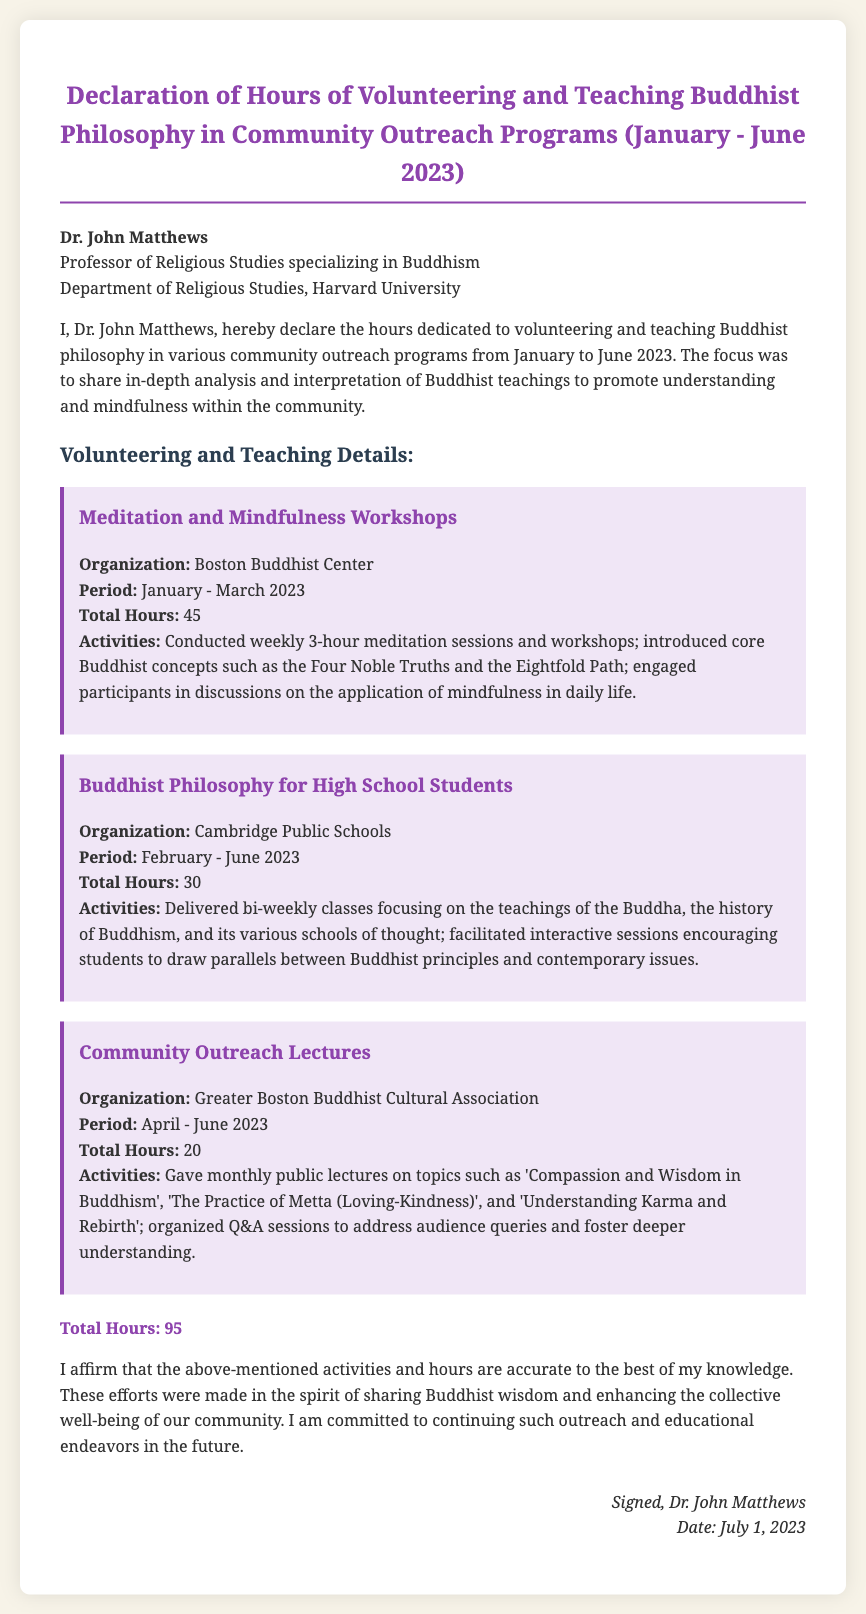What is the name of the professor? The document states that the professor's name is Dr. John Matthews.
Answer: Dr. John Matthews What is the total number of hours declared? The document specifies that the total hours of volunteering and teaching are 95.
Answer: 95 Which organization conducted the Meditation and Mindfulness Workshops? The organization mentioned for the workshops is the Boston Buddhist Center.
Answer: Boston Buddhist Center What was the teaching period for the high school classes? The document indicates that the period for the high school classes was February to June 2023.
Answer: February - June 2023 What was one of the topics covered in the Community Outreach Lectures? The document lists "Compassion and Wisdom in Buddhism" as one of the lecture topics.
Answer: Compassion and Wisdom in Buddhism How many total hours were dedicated to Community Outreach Lectures? According to the document, the total hours dedicated to the Community Outreach Lectures were 20.
Answer: 20 What type of activities were conducted in the Meditation and Mindfulness Workshops? The document describes the activities as conducting weekly meditation sessions and introducing core Buddhist concepts.
Answer: Weekly meditation sessions and introducing core Buddhist concepts What is the signature date on the declaration? The declaration states that the signature date is July 1, 2023.
Answer: July 1, 2023 How many bi-weekly classes were delivered for high school students? The document does not specify the exact number of classes, but indicates they were bi-weekly from February to June 2023.
Answer: Bi-weekly classes from February to June 2023 